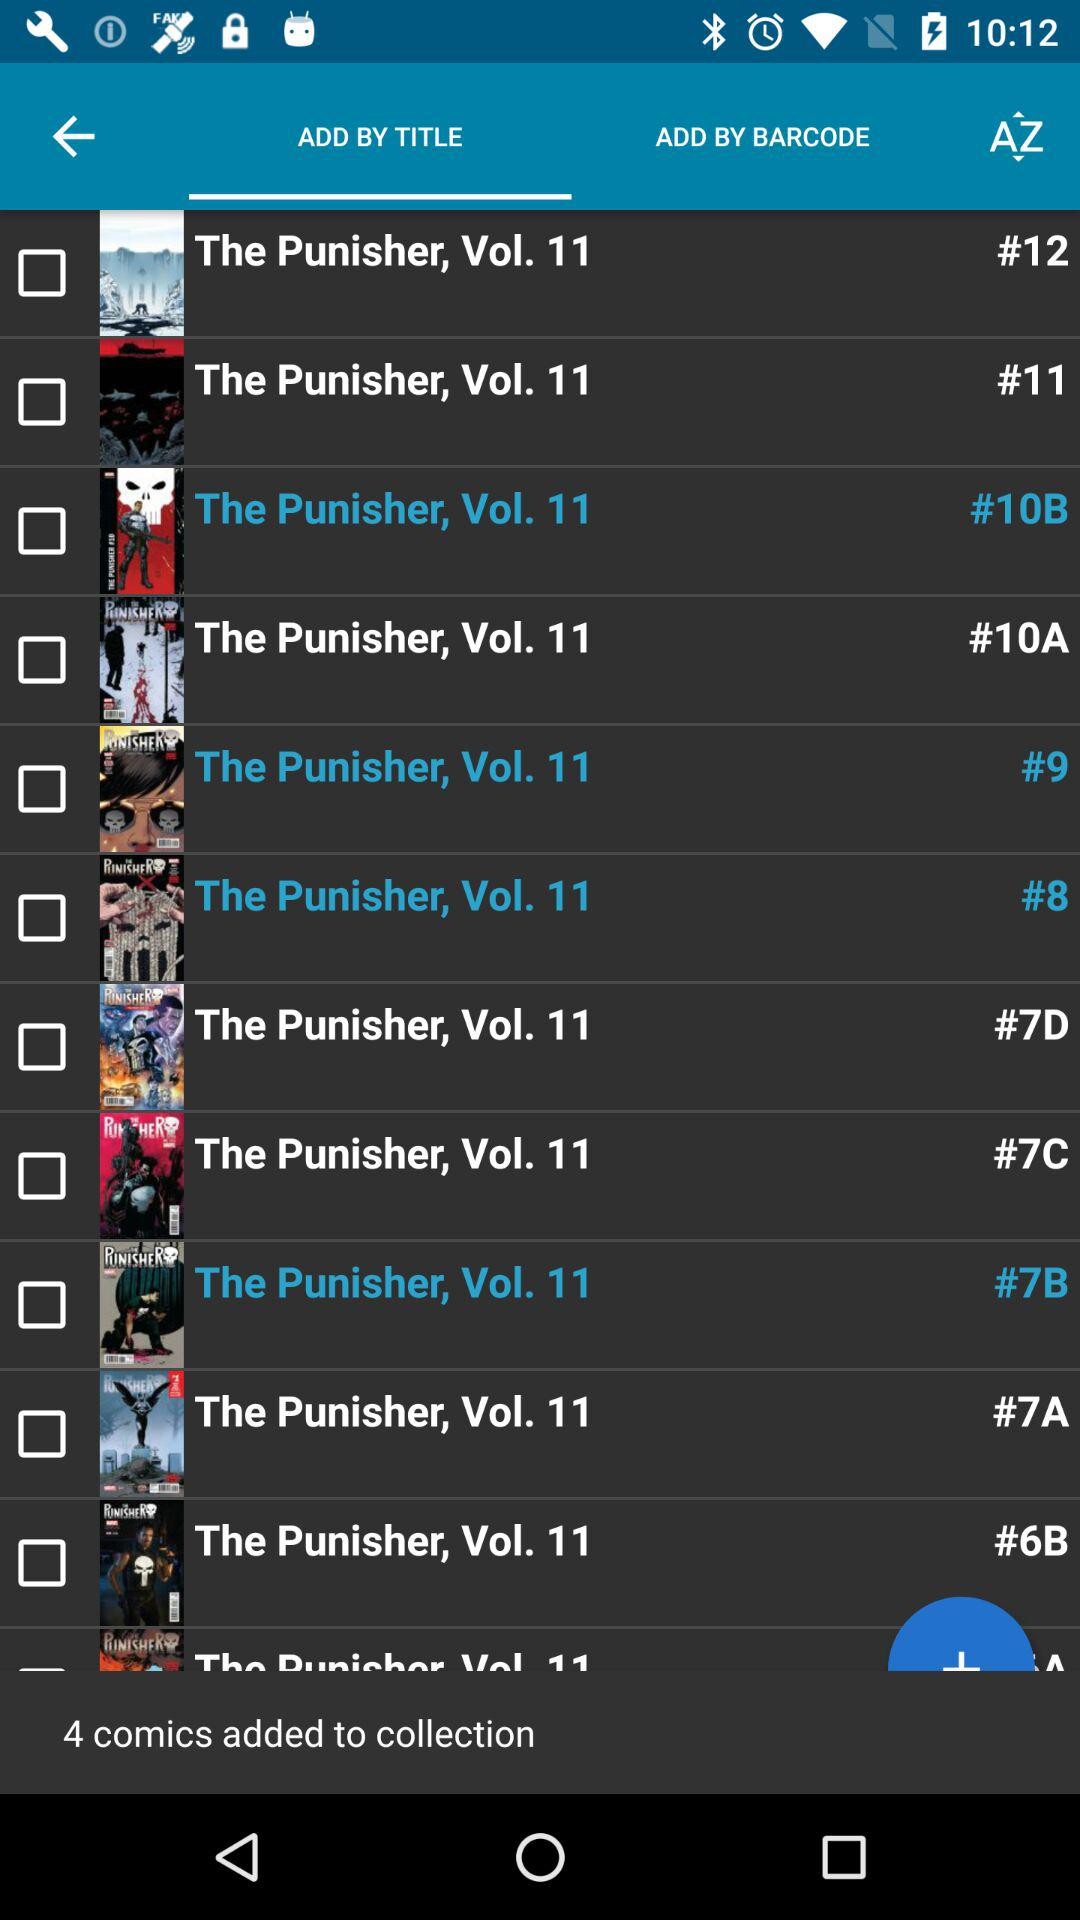Which tab is selected? The selected tab is "ADD BY TITLE". 